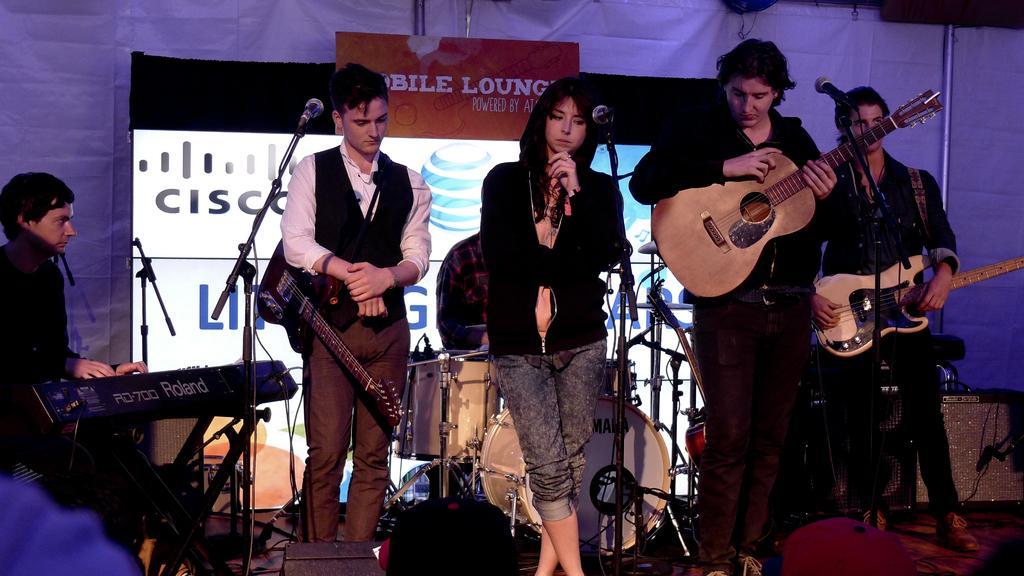Describe this image in one or two sentences. There are four people standing and two people are sitting. This is a guitar. This is a microphone. This is a musical band. 